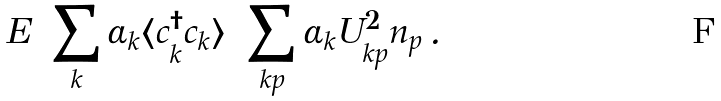<formula> <loc_0><loc_0><loc_500><loc_500>E = \sum _ { k } \alpha _ { k } \langle c ^ { \dagger } _ { k } c _ { k } \rangle = \sum _ { k p } \alpha _ { k } U ^ { 2 } _ { k p } n _ { p } \, .</formula> 